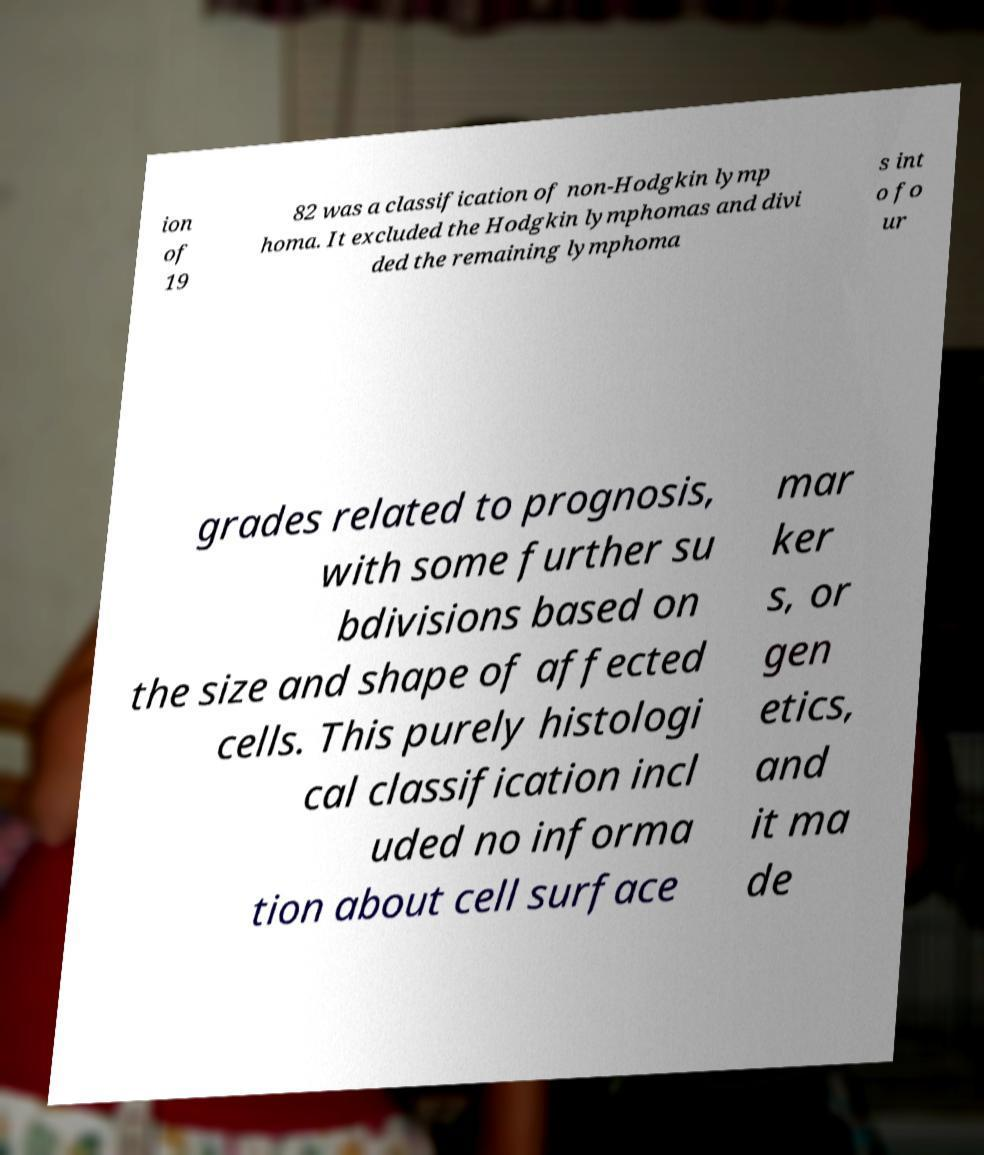I need the written content from this picture converted into text. Can you do that? ion of 19 82 was a classification of non-Hodgkin lymp homa. It excluded the Hodgkin lymphomas and divi ded the remaining lymphoma s int o fo ur grades related to prognosis, with some further su bdivisions based on the size and shape of affected cells. This purely histologi cal classification incl uded no informa tion about cell surface mar ker s, or gen etics, and it ma de 